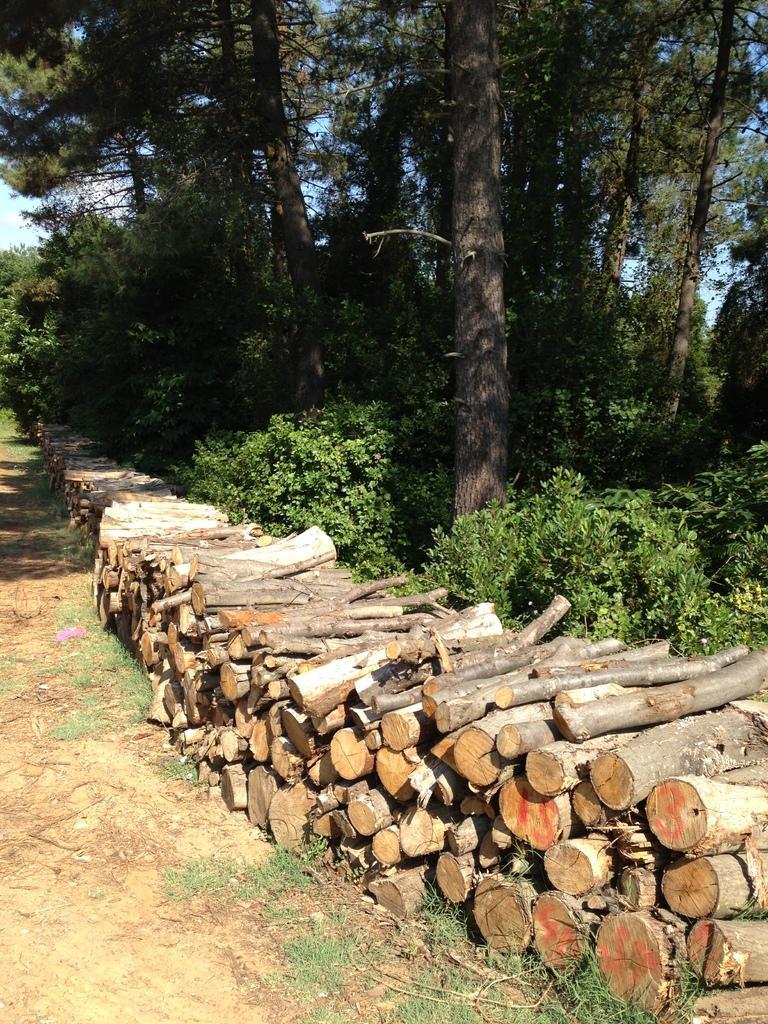Can you describe this image briefly? In this image we can see there are many wooden logs and there are many trees at the back. 